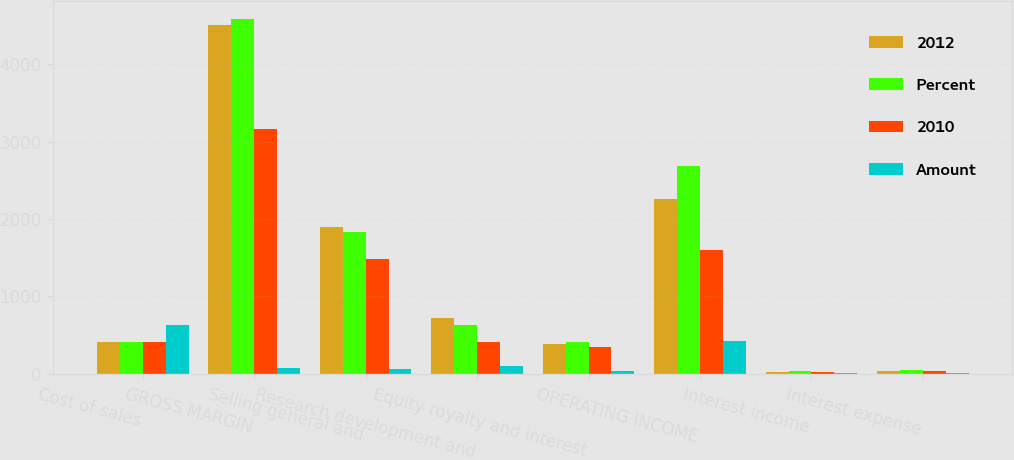<chart> <loc_0><loc_0><loc_500><loc_500><stacked_bar_chart><ecel><fcel>Cost of sales<fcel>GROSS MARGIN<fcel>Selling general and<fcel>Research development and<fcel>Equity royalty and interest<fcel>OPERATING INCOME<fcel>Interest income<fcel>Interest expense<nl><fcel>2012<fcel>414<fcel>4508<fcel>1900<fcel>728<fcel>384<fcel>2254<fcel>25<fcel>32<nl><fcel>Percent<fcel>414<fcel>4589<fcel>1837<fcel>629<fcel>416<fcel>2681<fcel>34<fcel>44<nl><fcel>2010<fcel>414<fcel>3168<fcel>1487<fcel>414<fcel>351<fcel>1602<fcel>21<fcel>40<nl><fcel>Amount<fcel>633<fcel>81<fcel>63<fcel>99<fcel>32<fcel>427<fcel>9<fcel>12<nl></chart> 